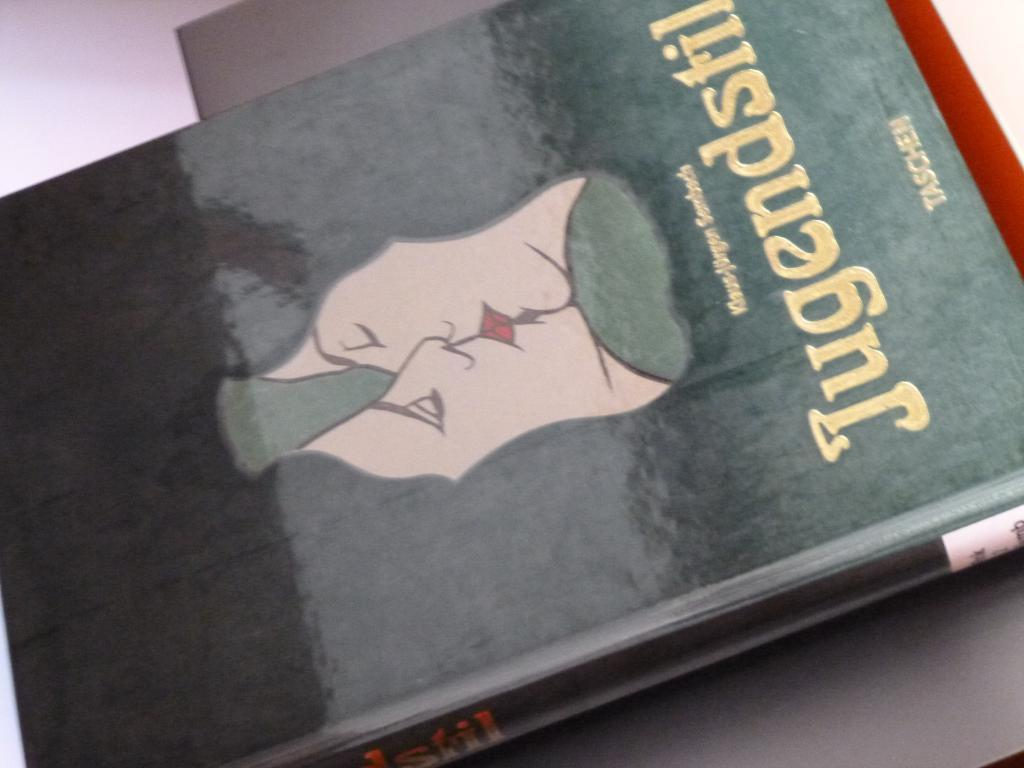What is present in the image related to reading material? There is a book in the image. Can you describe the position of the book in the image? The book is on an object. What can be seen on the cover of the book? There is a picture and words on the cover of the book. What type of breath can be heard coming from the book in the image? There is no breath coming from the book in the image, as books do not have the ability to breathe. 